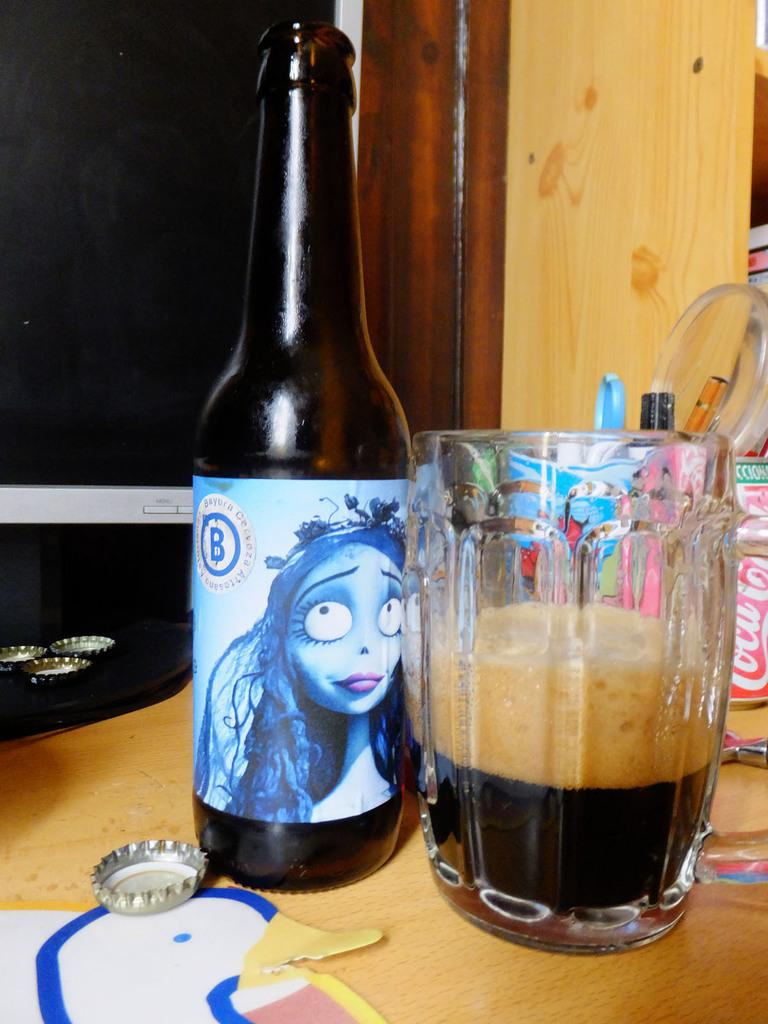<image>
Give a short and clear explanation of the subsequent image. A bottle of beer with Sally on it has a big blue letter B on the label. 